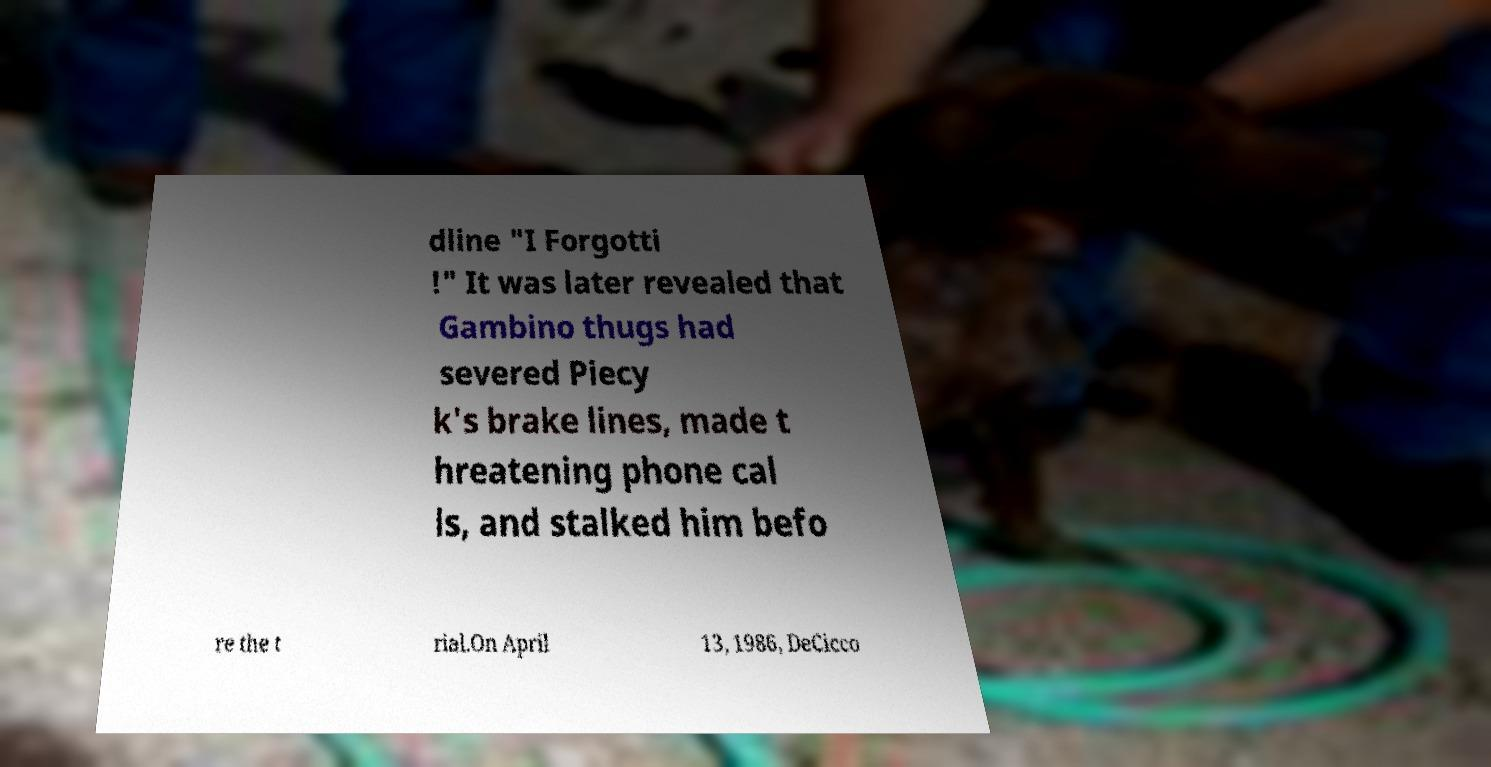Can you accurately transcribe the text from the provided image for me? dline "I Forgotti !" It was later revealed that Gambino thugs had severed Piecy k's brake lines, made t hreatening phone cal ls, and stalked him befo re the t rial.On April 13, 1986, DeCicco 